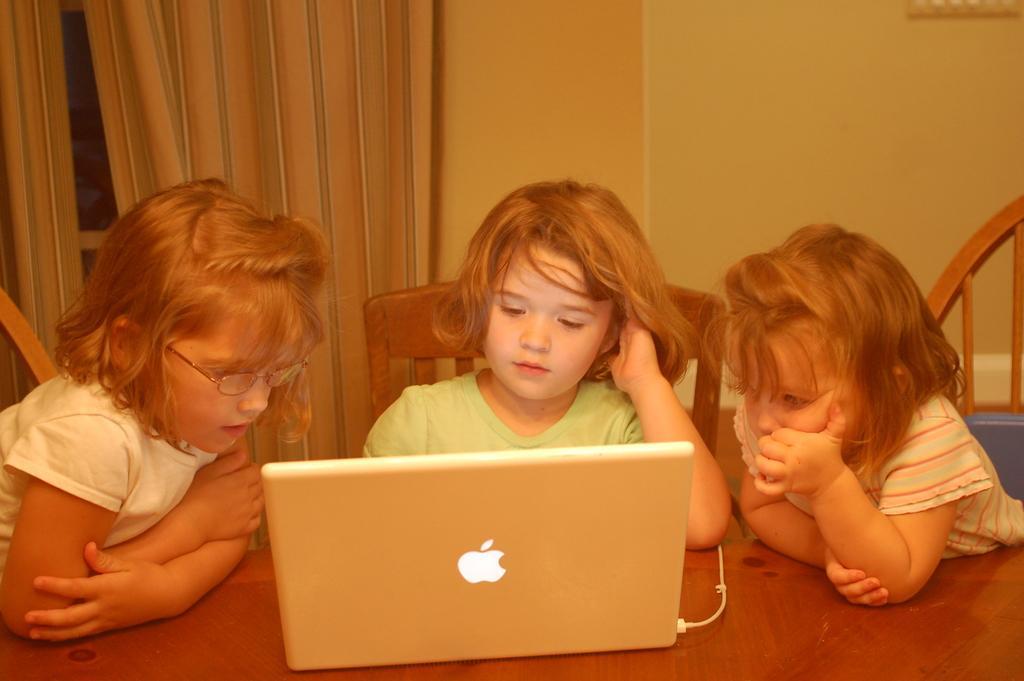In one or two sentences, can you explain what this image depicts? In this picture we can see three children and they are sitting on chairs, in front of them we can see a laptop on the table and in the background we can see the wall and a curtain. 